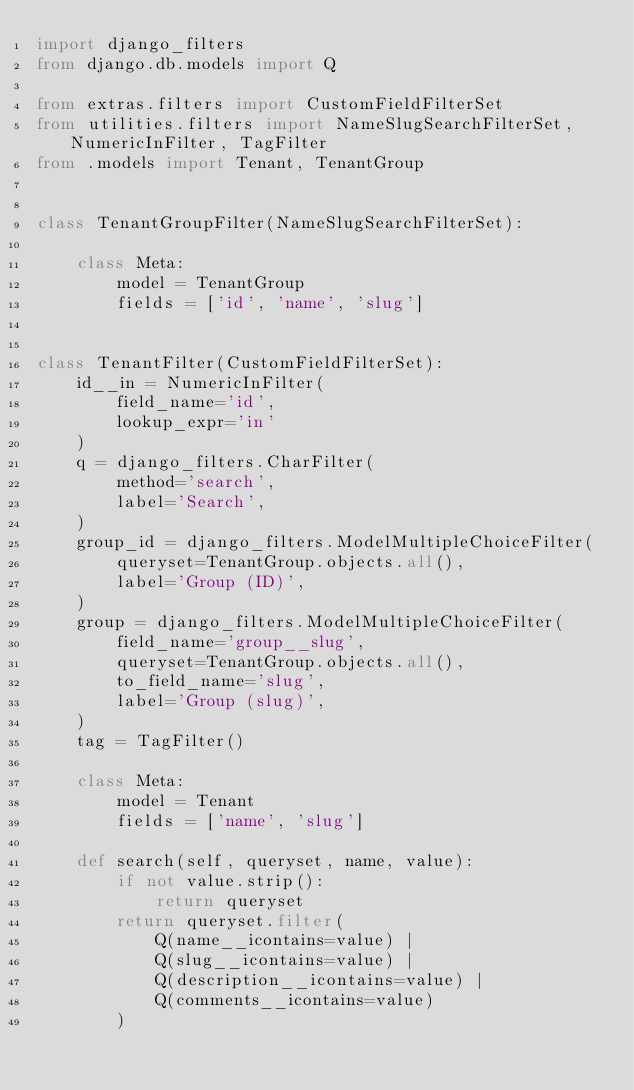<code> <loc_0><loc_0><loc_500><loc_500><_Python_>import django_filters
from django.db.models import Q

from extras.filters import CustomFieldFilterSet
from utilities.filters import NameSlugSearchFilterSet, NumericInFilter, TagFilter
from .models import Tenant, TenantGroup


class TenantGroupFilter(NameSlugSearchFilterSet):

    class Meta:
        model = TenantGroup
        fields = ['id', 'name', 'slug']


class TenantFilter(CustomFieldFilterSet):
    id__in = NumericInFilter(
        field_name='id',
        lookup_expr='in'
    )
    q = django_filters.CharFilter(
        method='search',
        label='Search',
    )
    group_id = django_filters.ModelMultipleChoiceFilter(
        queryset=TenantGroup.objects.all(),
        label='Group (ID)',
    )
    group = django_filters.ModelMultipleChoiceFilter(
        field_name='group__slug',
        queryset=TenantGroup.objects.all(),
        to_field_name='slug',
        label='Group (slug)',
    )
    tag = TagFilter()

    class Meta:
        model = Tenant
        fields = ['name', 'slug']

    def search(self, queryset, name, value):
        if not value.strip():
            return queryset
        return queryset.filter(
            Q(name__icontains=value) |
            Q(slug__icontains=value) |
            Q(description__icontains=value) |
            Q(comments__icontains=value)
        )
</code> 